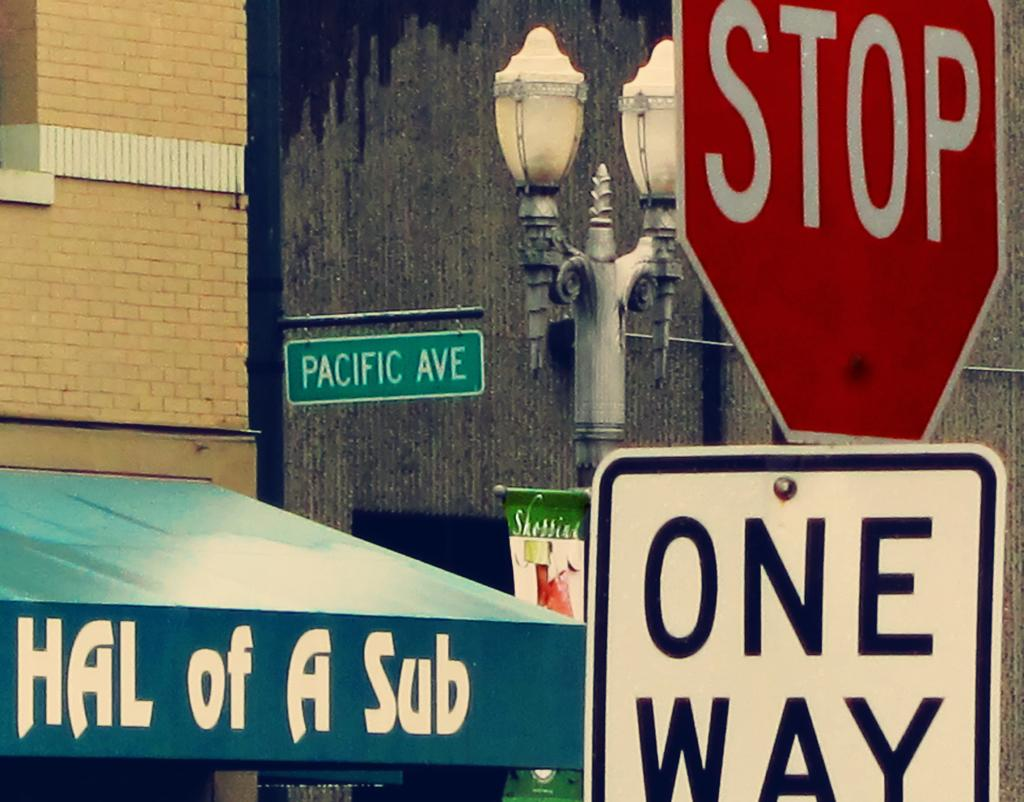<image>
Give a short and clear explanation of the subsequent image. A shop called Hal of A Sub at the street corner of Pacific Ave. 